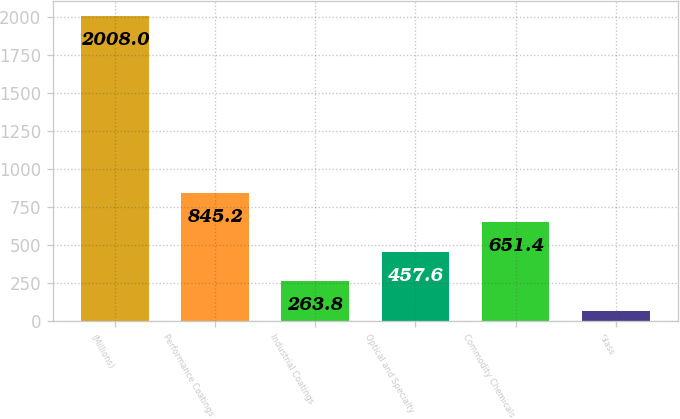Convert chart. <chart><loc_0><loc_0><loc_500><loc_500><bar_chart><fcel>(Millions)<fcel>Performance Coatings<fcel>Industrial Coatings<fcel>Optical and Specialty<fcel>Commodity Chemicals<fcel>Glass<nl><fcel>2008<fcel>845.2<fcel>263.8<fcel>457.6<fcel>651.4<fcel>70<nl></chart> 